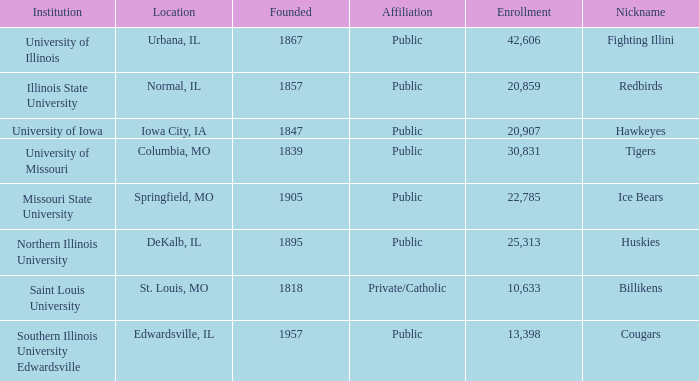What is the average enrollment of the Redbirds' school? 20859.0. 